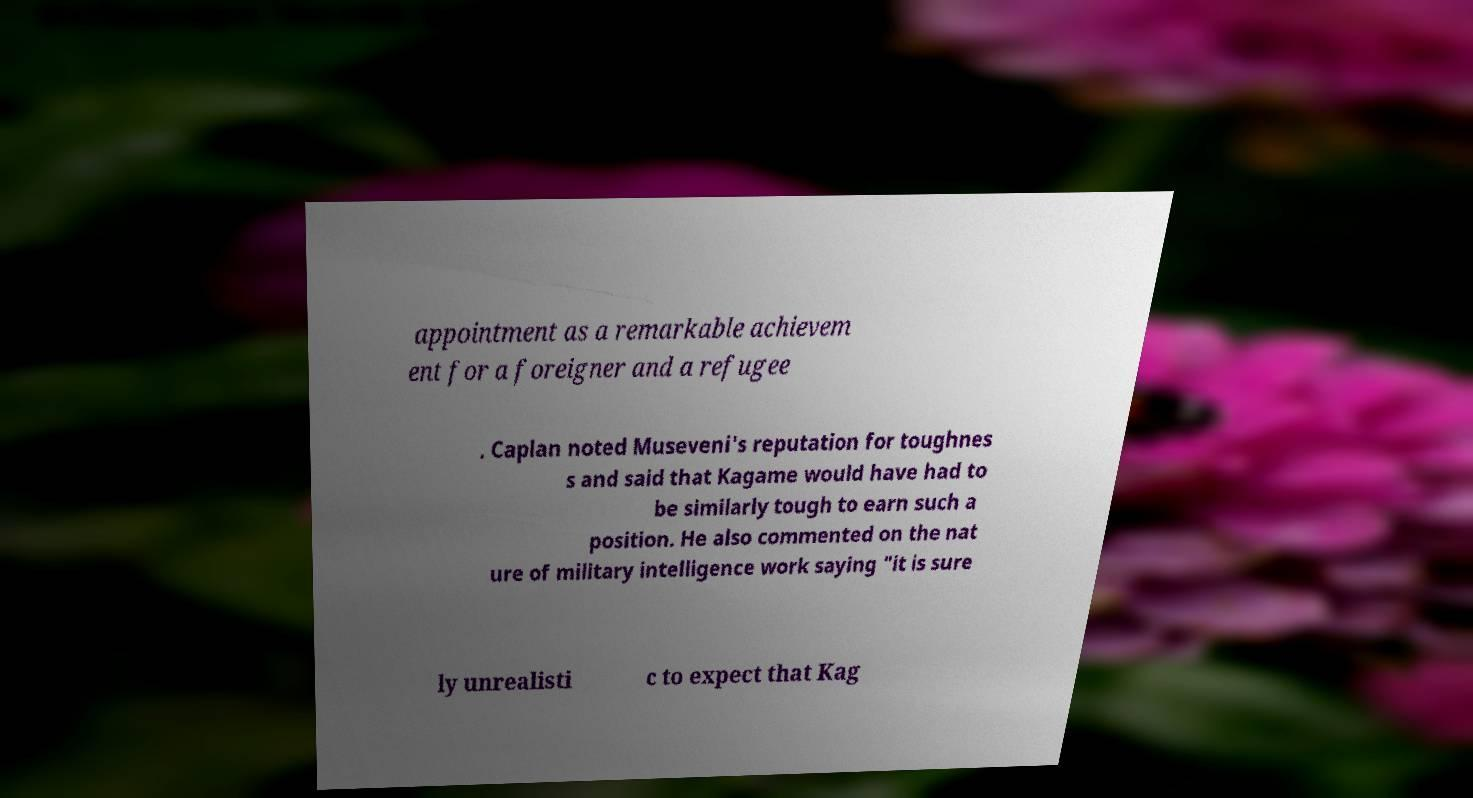I need the written content from this picture converted into text. Can you do that? appointment as a remarkable achievem ent for a foreigner and a refugee . Caplan noted Museveni's reputation for toughnes s and said that Kagame would have had to be similarly tough to earn such a position. He also commented on the nat ure of military intelligence work saying "it is sure ly unrealisti c to expect that Kag 